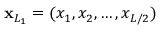<formula> <loc_0><loc_0><loc_500><loc_500>x _ { L _ { 1 } } = ( x _ { 1 } , x _ { 2 } , \dots , x _ { L / 2 } )</formula> 